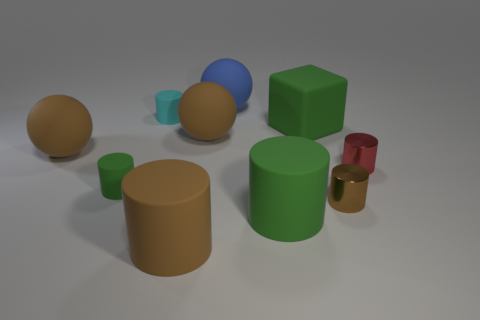Subtract 2 cylinders. How many cylinders are left? 4 Subtract all green matte cylinders. How many cylinders are left? 4 Subtract all brown cylinders. How many cylinders are left? 4 Subtract all cyan cylinders. Subtract all yellow cubes. How many cylinders are left? 5 Subtract all cylinders. How many objects are left? 4 Subtract 1 green blocks. How many objects are left? 9 Subtract all tiny yellow rubber things. Subtract all brown rubber objects. How many objects are left? 7 Add 8 red shiny cylinders. How many red shiny cylinders are left? 9 Add 7 metallic cylinders. How many metallic cylinders exist? 9 